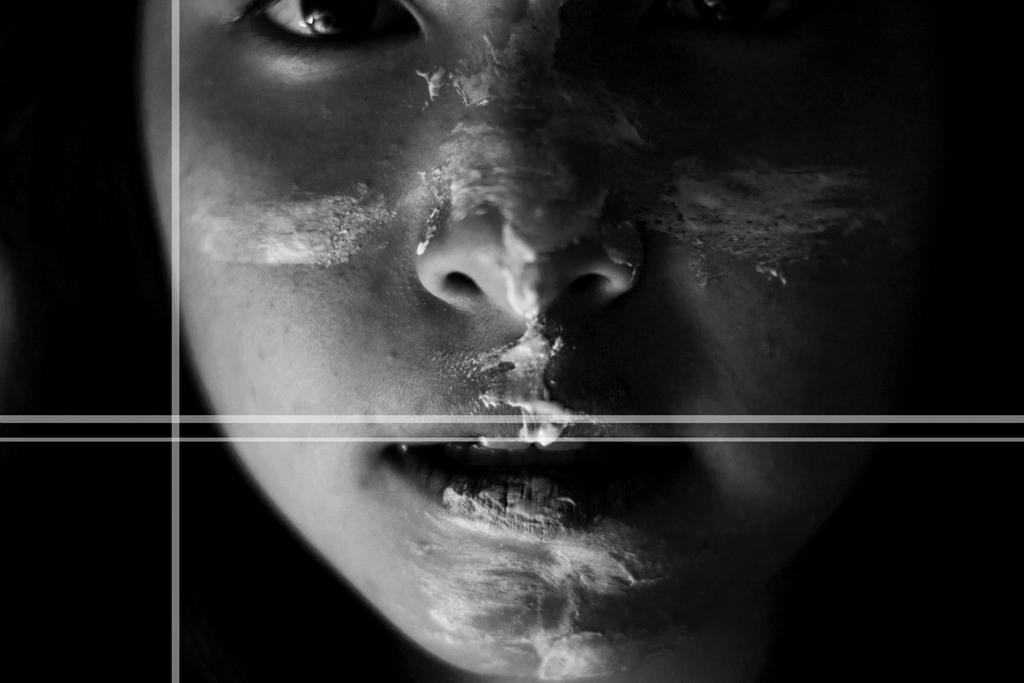What can be observed about the image's appearance? The image is edited. What is happening to the person in the image? There is cream on a person's face in the image. How many pigs can be seen in the image? There are no pigs present in the image. What is the condition of the cellar in the image? There is no mention of a cellar in the image. 